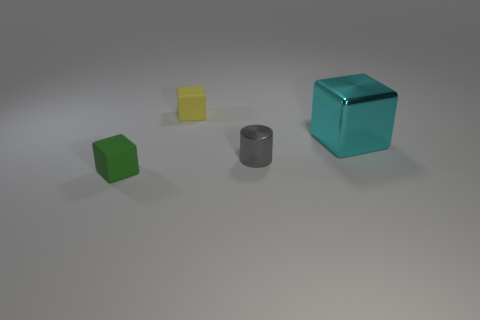Is the number of small matte cubes in front of the small metal thing less than the number of big cyan metallic objects to the right of the large cube?
Your response must be concise. No. What number of large cyan matte cubes are there?
Provide a succinct answer. 0. There is a small thing in front of the gray metal thing; what is its color?
Offer a terse response. Green. What size is the yellow object?
Your answer should be compact. Small. Do the small metal object and the metallic thing to the right of the small metal thing have the same color?
Your answer should be compact. No. What is the color of the tiny block that is right of the matte block that is in front of the cyan metallic cube?
Make the answer very short. Yellow. Is there anything else that has the same size as the green block?
Offer a very short reply. Yes. Does the object that is in front of the gray metal cylinder have the same shape as the yellow object?
Provide a succinct answer. Yes. How many metallic things are both behind the gray metallic thing and left of the large cyan metallic cube?
Offer a very short reply. 0. There is a rubber object that is left of the small matte object that is behind the rubber block on the left side of the tiny yellow matte cube; what color is it?
Keep it short and to the point. Green. 